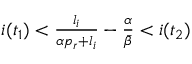Convert formula to latex. <formula><loc_0><loc_0><loc_500><loc_500>\begin{array} { r } { i ( t _ { 1 } ) < \frac { l _ { i } } { \alpha p _ { r } + l _ { i } } - \frac { \alpha } { \bar { \beta } } < i ( t _ { 2 } ) } \end{array}</formula> 